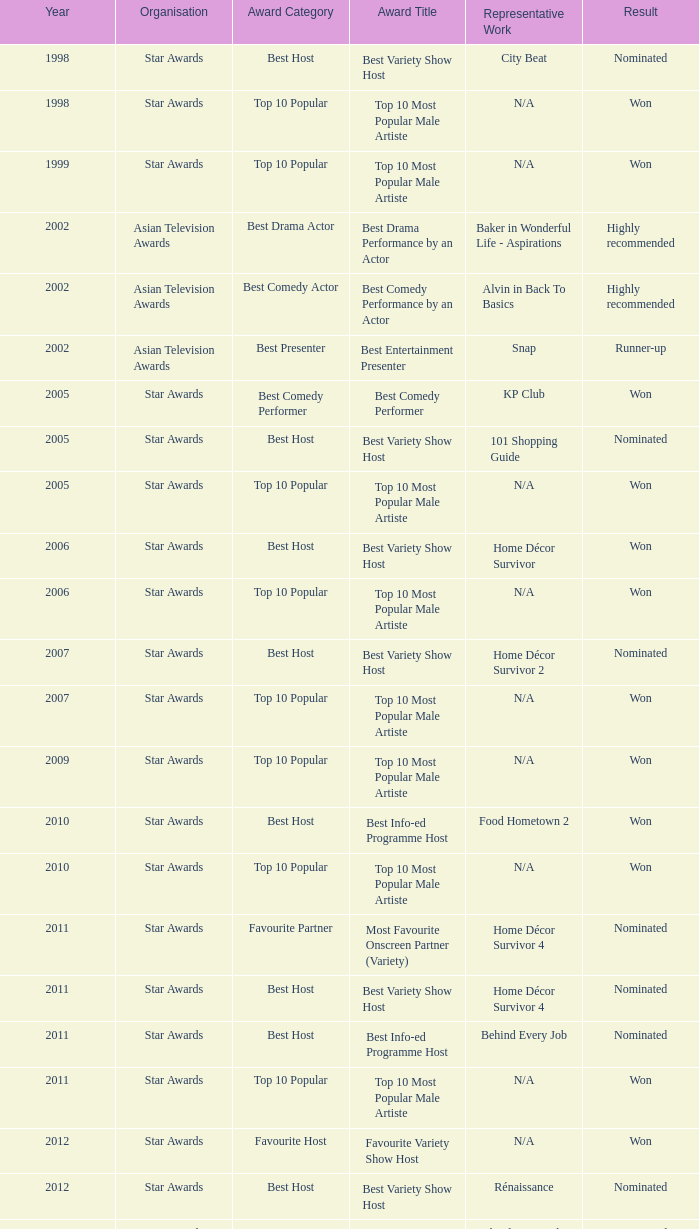What is the organisation in 2011 that was nominated and the award of best info-ed programme host? Star Awards. 